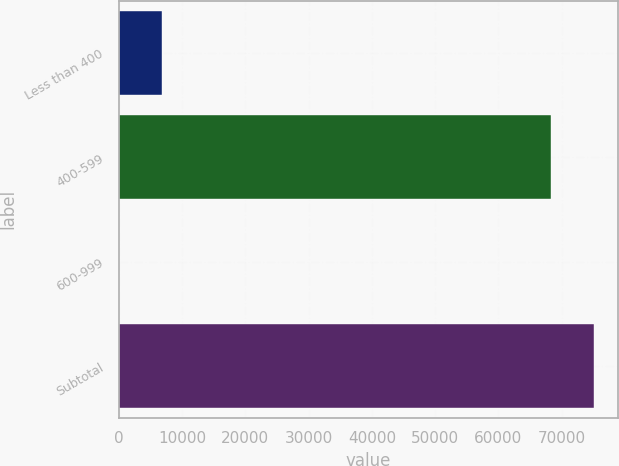<chart> <loc_0><loc_0><loc_500><loc_500><bar_chart><fcel>Less than 400<fcel>400-599<fcel>600-999<fcel>Subtotal<nl><fcel>6856.5<fcel>68335<fcel>3<fcel>75188.5<nl></chart> 